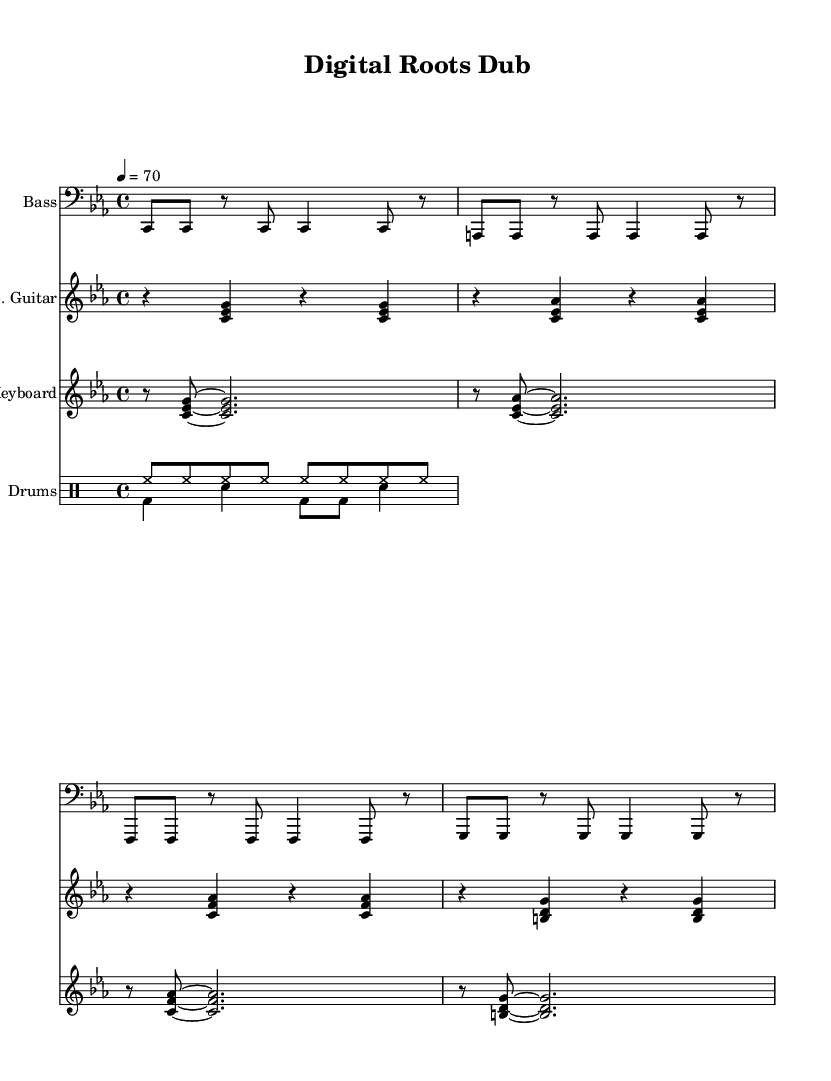What is the key signature of this music? The key signature is C minor, which is represented by three flats (B♭, E♭, A♭) in the music.
Answer: C minor What is the time signature of this music? The time signature is indicated at the beginning of the score. Here, it shows 4/4, which means there are four beats in each measure.
Answer: 4/4 What is the tempo marking for this piece? The tempo marking indicates the speed of the piece, which can be found written at the beginning. It shows a speed of 70 beats per minute, noted as "4 = 70".
Answer: 70 What is the main instrument playing the bass line? The bass line is played in the clef designated for bass instruments, specifically showing "Bass" in the instrument name.
Answer: Bass How many different instruments are featured in this score? The score features four distinct parts: Bass, Electric Guitar, Keyboard, and Drums. Each part is denoted at the beginning of their respective staff.
Answer: Four Describe the style of the drum pattern. The drum pattern consists of a hi-hat rhythm throughout and a kick-snare combination, indicative of dub reggae style which relies on repetitive beats and sparse arrangements.
Answer: Dub reggae What unique characteristic does the electric guitar feature in this piece? The electric guitar parts are played using chords, which gives it a harmonic support typical in reggae music, enhancing the overall sound through strumming patterns.
Answer: Chords 